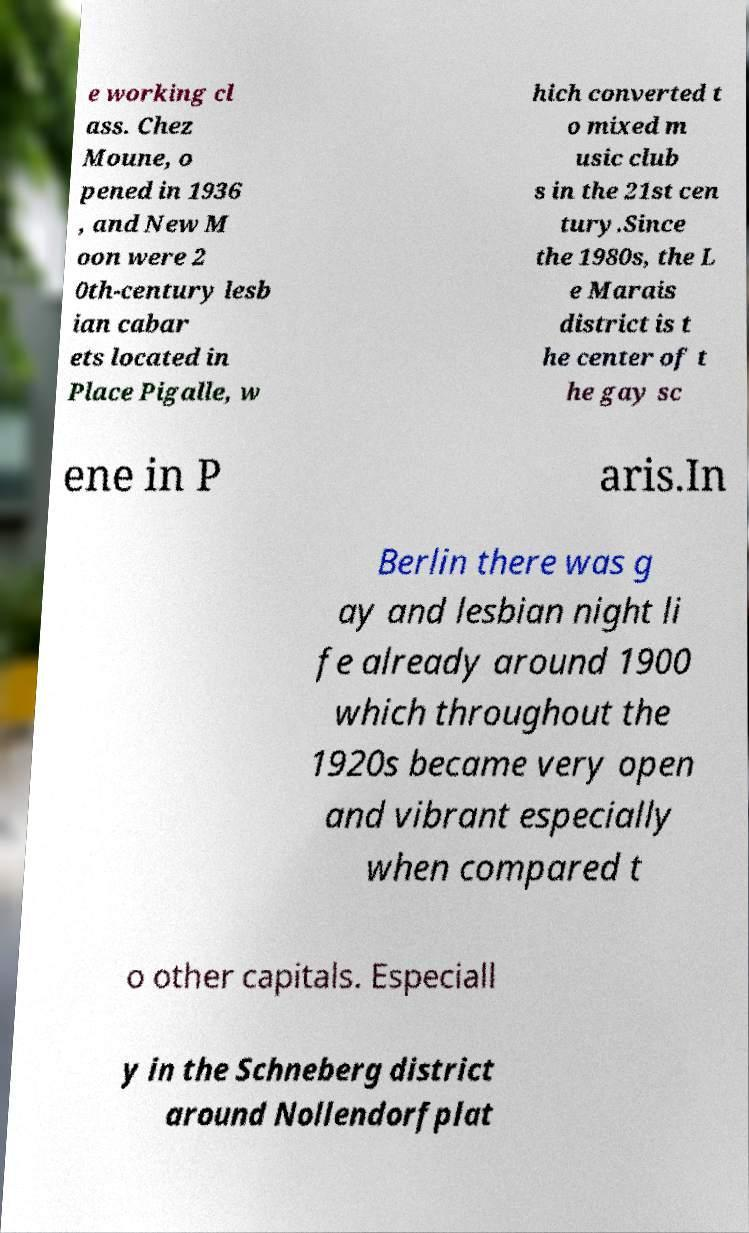What messages or text are displayed in this image? I need them in a readable, typed format. e working cl ass. Chez Moune, o pened in 1936 , and New M oon were 2 0th-century lesb ian cabar ets located in Place Pigalle, w hich converted t o mixed m usic club s in the 21st cen tury.Since the 1980s, the L e Marais district is t he center of t he gay sc ene in P aris.In Berlin there was g ay and lesbian night li fe already around 1900 which throughout the 1920s became very open and vibrant especially when compared t o other capitals. Especiall y in the Schneberg district around Nollendorfplat 